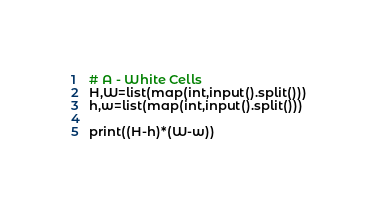<code> <loc_0><loc_0><loc_500><loc_500><_Python_># A - White Cells
H,W=list(map(int,input().split()))
h,w=list(map(int,input().split()))

print((H-h)*(W-w))
</code> 